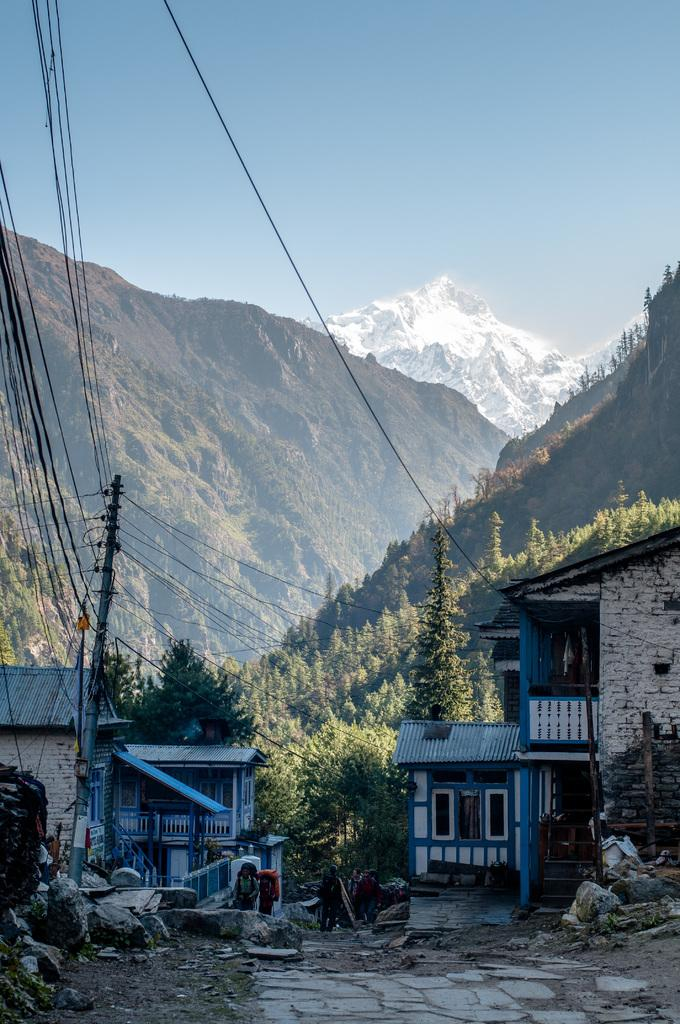What structures can be seen on both sides of the image? There are houses on both the right and left hand side of the image. What is located on the left hand side of the image, besides the houses? There is an electric pole on the left hand side of the image. What type of natural feature can be seen in the background of the image? There are mountains in the background of the image. What is visible in the sky in the image? The sky is clear and visible in the image. How many government tickets are visible in the image? There are no government tickets present in the image. What type of oven can be seen in the background of the image? There is no oven present in the image; it features houses, an electric pole, mountains, and a clear sky. 